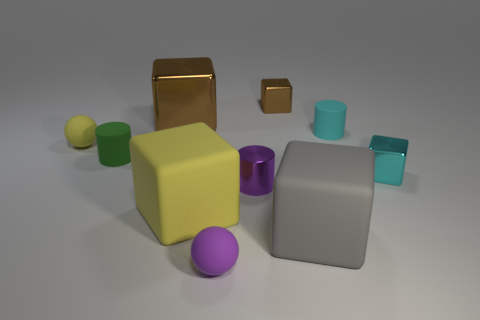Subtract all cyan cylinders. How many cylinders are left? 2 Subtract all cyan blocks. How many blocks are left? 4 Subtract 5 blocks. How many blocks are left? 0 Subtract all cylinders. How many objects are left? 7 Subtract all gray cylinders. Subtract all brown cubes. How many cylinders are left? 3 Subtract all red blocks. How many green balls are left? 0 Add 8 large green metallic things. How many large green metallic things exist? 8 Subtract 0 blue cylinders. How many objects are left? 10 Subtract all tiny blue metal things. Subtract all green things. How many objects are left? 9 Add 1 large yellow matte blocks. How many large yellow matte blocks are left? 2 